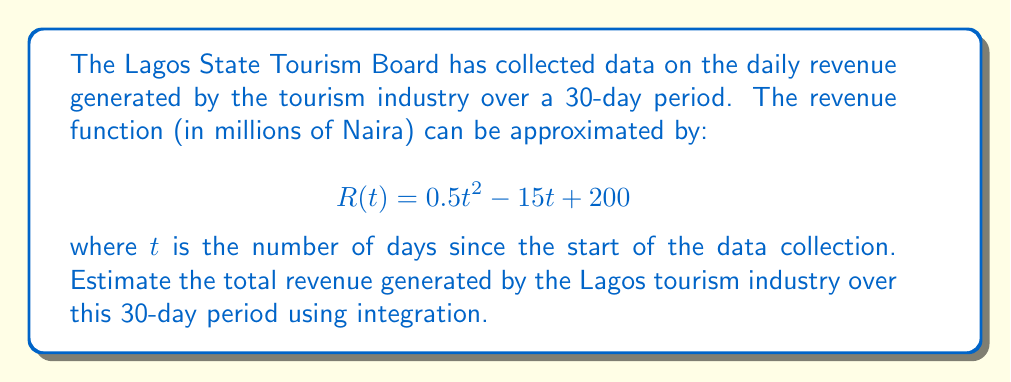Provide a solution to this math problem. To solve this problem, we need to integrate the revenue function over the given time period. Here's a step-by-step approach:

1. The total revenue is the area under the curve of $R(t)$ from $t=0$ to $t=30$.

2. We can find this by calculating the definite integral:

   $$\int_0^{30} R(t) dt = \int_0^{30} (0.5t^2 - 15t + 200) dt$$

3. Let's integrate each term separately:
   
   $$\int_0^{30} 0.5t^2 dt = 0.5 \cdot \frac{t^3}{3} \bigg|_0^{30}$$
   $$\int_0^{30} -15t dt = -15 \cdot \frac{t^2}{2} \bigg|_0^{30}$$
   $$\int_0^{30} 200 dt = 200t \bigg|_0^{30}$$

4. Now, let's evaluate each term:

   $$0.5 \cdot \frac{t^3}{3} \bigg|_0^{30} = 0.5 \cdot \frac{30^3}{3} - 0 = 4500$$
   $$-15 \cdot \frac{t^2}{2} \bigg|_0^{30} = -15 \cdot \frac{30^2}{2} - 0 = -6750$$
   $$200t \bigg|_0^{30} = 200 \cdot 30 - 0 = 6000$$

5. Sum up all the terms:

   $$4500 - 6750 + 6000 = 3750$$

Therefore, the total revenue generated over the 30-day period is 3750 million Naira.
Answer: The total revenue generated by the Lagos tourism industry over the 30-day period is approximately 3750 million Naira. 